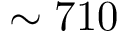<formula> <loc_0><loc_0><loc_500><loc_500>\sim 7 1 0</formula> 